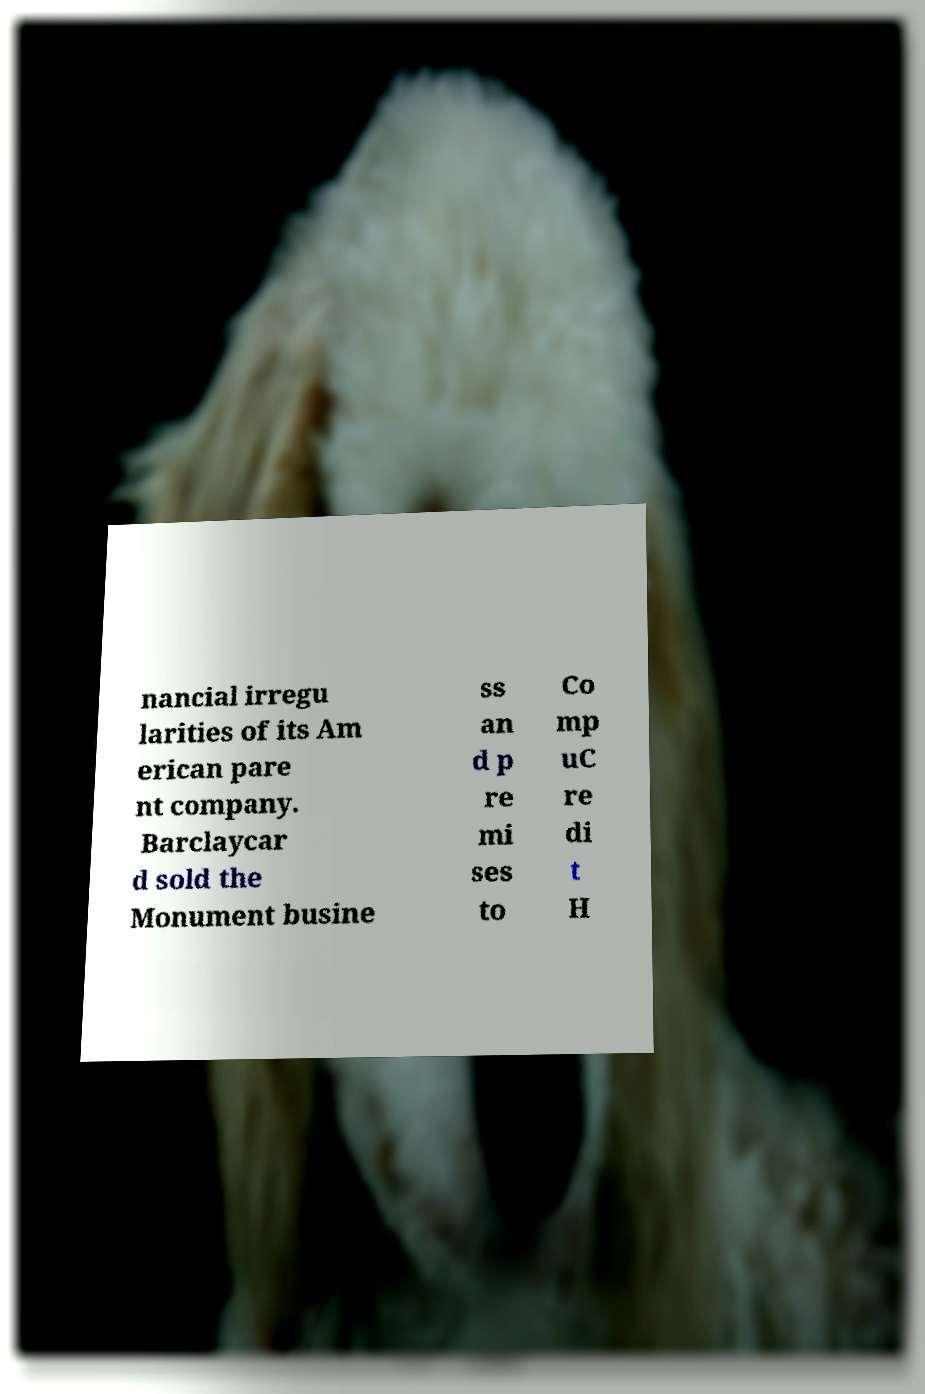Can you read and provide the text displayed in the image?This photo seems to have some interesting text. Can you extract and type it out for me? nancial irregu larities of its Am erican pare nt company. Barclaycar d sold the Monument busine ss an d p re mi ses to Co mp uC re di t H 